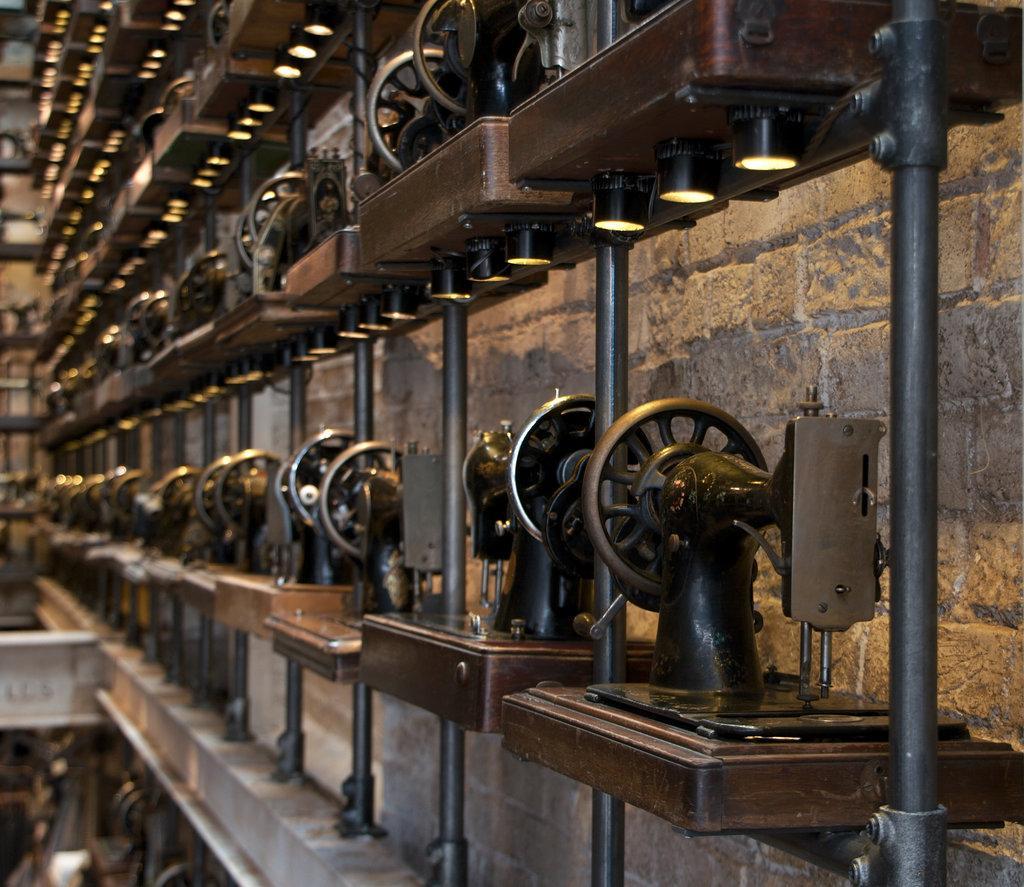How would you summarize this image in a sentence or two? This image consists of many sewing machines arranged in a line to the rods. And there are lights, at the bottom of each machine. 